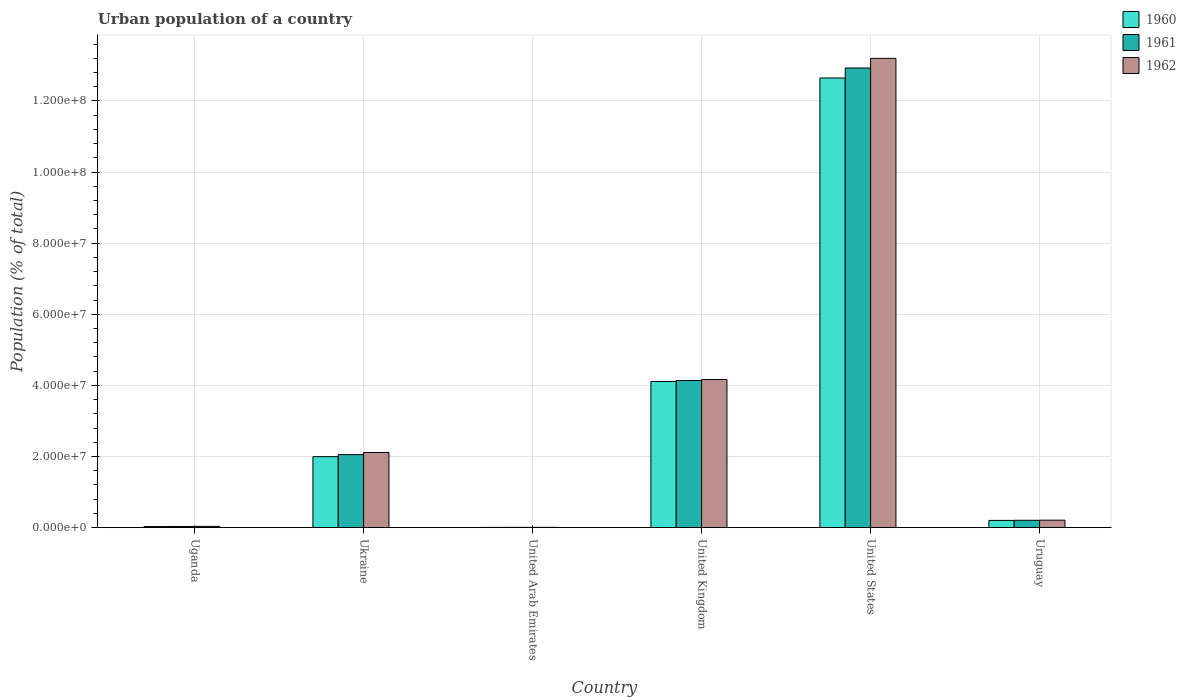How many different coloured bars are there?
Offer a very short reply. 3. How many groups of bars are there?
Your answer should be compact. 6. Are the number of bars on each tick of the X-axis equal?
Ensure brevity in your answer.  Yes. How many bars are there on the 3rd tick from the left?
Your response must be concise. 3. What is the label of the 1st group of bars from the left?
Ensure brevity in your answer.  Uganda. What is the urban population in 1960 in United Arab Emirates?
Give a very brief answer. 6.81e+04. Across all countries, what is the maximum urban population in 1961?
Your answer should be very brief. 1.29e+08. Across all countries, what is the minimum urban population in 1961?
Provide a succinct answer. 7.51e+04. In which country was the urban population in 1960 minimum?
Offer a terse response. United Arab Emirates. What is the total urban population in 1961 in the graph?
Keep it short and to the point. 1.94e+08. What is the difference between the urban population in 1961 in United Arab Emirates and that in Uruguay?
Offer a very short reply. -1.99e+06. What is the difference between the urban population in 1962 in Uganda and the urban population in 1960 in Uruguay?
Keep it short and to the point. -1.69e+06. What is the average urban population in 1960 per country?
Your answer should be very brief. 3.17e+07. What is the difference between the urban population of/in 1962 and urban population of/in 1960 in Uruguay?
Your answer should be very brief. 6.38e+04. What is the ratio of the urban population in 1962 in Uganda to that in United States?
Give a very brief answer. 0. Is the urban population in 1962 in Uganda less than that in Ukraine?
Offer a very short reply. Yes. What is the difference between the highest and the second highest urban population in 1962?
Make the answer very short. -2.05e+07. What is the difference between the highest and the lowest urban population in 1961?
Give a very brief answer. 1.29e+08. In how many countries, is the urban population in 1962 greater than the average urban population in 1962 taken over all countries?
Provide a short and direct response. 2. Is the sum of the urban population in 1961 in Uganda and Ukraine greater than the maximum urban population in 1962 across all countries?
Your response must be concise. No. What does the 1st bar from the left in United Kingdom represents?
Provide a succinct answer. 1960. Is it the case that in every country, the sum of the urban population in 1960 and urban population in 1962 is greater than the urban population in 1961?
Your answer should be compact. Yes. How many bars are there?
Offer a very short reply. 18. Are all the bars in the graph horizontal?
Your answer should be very brief. No. Are the values on the major ticks of Y-axis written in scientific E-notation?
Make the answer very short. Yes. Where does the legend appear in the graph?
Ensure brevity in your answer.  Top right. How many legend labels are there?
Provide a succinct answer. 3. How are the legend labels stacked?
Provide a succinct answer. Vertical. What is the title of the graph?
Offer a very short reply. Urban population of a country. Does "1982" appear as one of the legend labels in the graph?
Give a very brief answer. No. What is the label or title of the Y-axis?
Provide a short and direct response. Population (% of total). What is the Population (% of total) of 1960 in Uganda?
Offer a terse response. 3.00e+05. What is the Population (% of total) of 1961 in Uganda?
Your answer should be compact. 3.23e+05. What is the Population (% of total) of 1962 in Uganda?
Your answer should be compact. 3.49e+05. What is the Population (% of total) of 1960 in Ukraine?
Ensure brevity in your answer.  2.00e+07. What is the Population (% of total) of 1961 in Ukraine?
Provide a short and direct response. 2.05e+07. What is the Population (% of total) of 1962 in Ukraine?
Offer a very short reply. 2.11e+07. What is the Population (% of total) in 1960 in United Arab Emirates?
Ensure brevity in your answer.  6.81e+04. What is the Population (% of total) of 1961 in United Arab Emirates?
Offer a very short reply. 7.51e+04. What is the Population (% of total) of 1962 in United Arab Emirates?
Make the answer very short. 8.45e+04. What is the Population (% of total) of 1960 in United Kingdom?
Offer a very short reply. 4.11e+07. What is the Population (% of total) of 1961 in United Kingdom?
Give a very brief answer. 4.14e+07. What is the Population (% of total) in 1962 in United Kingdom?
Give a very brief answer. 4.17e+07. What is the Population (% of total) in 1960 in United States?
Give a very brief answer. 1.26e+08. What is the Population (% of total) of 1961 in United States?
Your answer should be very brief. 1.29e+08. What is the Population (% of total) of 1962 in United States?
Make the answer very short. 1.32e+08. What is the Population (% of total) in 1960 in Uruguay?
Your response must be concise. 2.04e+06. What is the Population (% of total) in 1961 in Uruguay?
Give a very brief answer. 2.07e+06. What is the Population (% of total) of 1962 in Uruguay?
Make the answer very short. 2.10e+06. Across all countries, what is the maximum Population (% of total) in 1960?
Your answer should be very brief. 1.26e+08. Across all countries, what is the maximum Population (% of total) in 1961?
Your answer should be very brief. 1.29e+08. Across all countries, what is the maximum Population (% of total) of 1962?
Your answer should be compact. 1.32e+08. Across all countries, what is the minimum Population (% of total) in 1960?
Offer a very short reply. 6.81e+04. Across all countries, what is the minimum Population (% of total) of 1961?
Make the answer very short. 7.51e+04. Across all countries, what is the minimum Population (% of total) of 1962?
Make the answer very short. 8.45e+04. What is the total Population (% of total) in 1960 in the graph?
Keep it short and to the point. 1.90e+08. What is the total Population (% of total) in 1961 in the graph?
Make the answer very short. 1.94e+08. What is the total Population (% of total) of 1962 in the graph?
Your response must be concise. 1.97e+08. What is the difference between the Population (% of total) of 1960 in Uganda and that in Ukraine?
Give a very brief answer. -1.97e+07. What is the difference between the Population (% of total) in 1961 in Uganda and that in Ukraine?
Give a very brief answer. -2.02e+07. What is the difference between the Population (% of total) in 1962 in Uganda and that in Ukraine?
Ensure brevity in your answer.  -2.08e+07. What is the difference between the Population (% of total) in 1960 in Uganda and that in United Arab Emirates?
Offer a very short reply. 2.32e+05. What is the difference between the Population (% of total) of 1961 in Uganda and that in United Arab Emirates?
Your answer should be compact. 2.48e+05. What is the difference between the Population (% of total) of 1962 in Uganda and that in United Arab Emirates?
Your answer should be compact. 2.65e+05. What is the difference between the Population (% of total) in 1960 in Uganda and that in United Kingdom?
Make the answer very short. -4.08e+07. What is the difference between the Population (% of total) in 1961 in Uganda and that in United Kingdom?
Give a very brief answer. -4.11e+07. What is the difference between the Population (% of total) of 1962 in Uganda and that in United Kingdom?
Offer a terse response. -4.13e+07. What is the difference between the Population (% of total) in 1960 in Uganda and that in United States?
Your answer should be compact. -1.26e+08. What is the difference between the Population (% of total) in 1961 in Uganda and that in United States?
Offer a very short reply. -1.29e+08. What is the difference between the Population (% of total) in 1962 in Uganda and that in United States?
Provide a short and direct response. -1.32e+08. What is the difference between the Population (% of total) of 1960 in Uganda and that in Uruguay?
Your answer should be very brief. -1.74e+06. What is the difference between the Population (% of total) in 1961 in Uganda and that in Uruguay?
Make the answer very short. -1.75e+06. What is the difference between the Population (% of total) of 1962 in Uganda and that in Uruguay?
Give a very brief answer. -1.75e+06. What is the difference between the Population (% of total) of 1960 in Ukraine and that in United Arab Emirates?
Offer a very short reply. 1.99e+07. What is the difference between the Population (% of total) of 1961 in Ukraine and that in United Arab Emirates?
Provide a succinct answer. 2.05e+07. What is the difference between the Population (% of total) in 1962 in Ukraine and that in United Arab Emirates?
Your answer should be compact. 2.10e+07. What is the difference between the Population (% of total) of 1960 in Ukraine and that in United Kingdom?
Offer a terse response. -2.11e+07. What is the difference between the Population (% of total) in 1961 in Ukraine and that in United Kingdom?
Ensure brevity in your answer.  -2.08e+07. What is the difference between the Population (% of total) in 1962 in Ukraine and that in United Kingdom?
Provide a short and direct response. -2.05e+07. What is the difference between the Population (% of total) in 1960 in Ukraine and that in United States?
Your answer should be compact. -1.06e+08. What is the difference between the Population (% of total) of 1961 in Ukraine and that in United States?
Give a very brief answer. -1.09e+08. What is the difference between the Population (% of total) of 1962 in Ukraine and that in United States?
Provide a short and direct response. -1.11e+08. What is the difference between the Population (% of total) in 1960 in Ukraine and that in Uruguay?
Offer a terse response. 1.79e+07. What is the difference between the Population (% of total) in 1961 in Ukraine and that in Uruguay?
Ensure brevity in your answer.  1.85e+07. What is the difference between the Population (% of total) of 1962 in Ukraine and that in Uruguay?
Ensure brevity in your answer.  1.90e+07. What is the difference between the Population (% of total) in 1960 in United Arab Emirates and that in United Kingdom?
Keep it short and to the point. -4.10e+07. What is the difference between the Population (% of total) in 1961 in United Arab Emirates and that in United Kingdom?
Your answer should be very brief. -4.13e+07. What is the difference between the Population (% of total) of 1962 in United Arab Emirates and that in United Kingdom?
Offer a very short reply. -4.16e+07. What is the difference between the Population (% of total) of 1960 in United Arab Emirates and that in United States?
Provide a succinct answer. -1.26e+08. What is the difference between the Population (% of total) of 1961 in United Arab Emirates and that in United States?
Make the answer very short. -1.29e+08. What is the difference between the Population (% of total) in 1962 in United Arab Emirates and that in United States?
Offer a terse response. -1.32e+08. What is the difference between the Population (% of total) in 1960 in United Arab Emirates and that in Uruguay?
Your answer should be very brief. -1.97e+06. What is the difference between the Population (% of total) of 1961 in United Arab Emirates and that in Uruguay?
Your answer should be very brief. -1.99e+06. What is the difference between the Population (% of total) of 1962 in United Arab Emirates and that in Uruguay?
Provide a short and direct response. -2.02e+06. What is the difference between the Population (% of total) in 1960 in United Kingdom and that in United States?
Keep it short and to the point. -8.54e+07. What is the difference between the Population (% of total) of 1961 in United Kingdom and that in United States?
Give a very brief answer. -8.79e+07. What is the difference between the Population (% of total) in 1962 in United Kingdom and that in United States?
Keep it short and to the point. -9.03e+07. What is the difference between the Population (% of total) in 1960 in United Kingdom and that in Uruguay?
Your answer should be very brief. 3.91e+07. What is the difference between the Population (% of total) in 1961 in United Kingdom and that in Uruguay?
Offer a terse response. 3.93e+07. What is the difference between the Population (% of total) of 1962 in United Kingdom and that in Uruguay?
Make the answer very short. 3.96e+07. What is the difference between the Population (% of total) of 1960 in United States and that in Uruguay?
Make the answer very short. 1.24e+08. What is the difference between the Population (% of total) in 1961 in United States and that in Uruguay?
Provide a succinct answer. 1.27e+08. What is the difference between the Population (% of total) in 1962 in United States and that in Uruguay?
Your answer should be very brief. 1.30e+08. What is the difference between the Population (% of total) of 1960 in Uganda and the Population (% of total) of 1961 in Ukraine?
Offer a terse response. -2.02e+07. What is the difference between the Population (% of total) in 1960 in Uganda and the Population (% of total) in 1962 in Ukraine?
Your response must be concise. -2.08e+07. What is the difference between the Population (% of total) of 1961 in Uganda and the Population (% of total) of 1962 in Ukraine?
Provide a succinct answer. -2.08e+07. What is the difference between the Population (% of total) in 1960 in Uganda and the Population (% of total) in 1961 in United Arab Emirates?
Your answer should be very brief. 2.25e+05. What is the difference between the Population (% of total) of 1960 in Uganda and the Population (% of total) of 1962 in United Arab Emirates?
Offer a terse response. 2.15e+05. What is the difference between the Population (% of total) in 1961 in Uganda and the Population (% of total) in 1962 in United Arab Emirates?
Your response must be concise. 2.39e+05. What is the difference between the Population (% of total) of 1960 in Uganda and the Population (% of total) of 1961 in United Kingdom?
Make the answer very short. -4.11e+07. What is the difference between the Population (% of total) of 1960 in Uganda and the Population (% of total) of 1962 in United Kingdom?
Offer a very short reply. -4.14e+07. What is the difference between the Population (% of total) in 1961 in Uganda and the Population (% of total) in 1962 in United Kingdom?
Give a very brief answer. -4.13e+07. What is the difference between the Population (% of total) in 1960 in Uganda and the Population (% of total) in 1961 in United States?
Provide a succinct answer. -1.29e+08. What is the difference between the Population (% of total) of 1960 in Uganda and the Population (% of total) of 1962 in United States?
Provide a succinct answer. -1.32e+08. What is the difference between the Population (% of total) of 1961 in Uganda and the Population (% of total) of 1962 in United States?
Provide a short and direct response. -1.32e+08. What is the difference between the Population (% of total) in 1960 in Uganda and the Population (% of total) in 1961 in Uruguay?
Give a very brief answer. -1.77e+06. What is the difference between the Population (% of total) of 1960 in Uganda and the Population (% of total) of 1962 in Uruguay?
Make the answer very short. -1.80e+06. What is the difference between the Population (% of total) in 1961 in Uganda and the Population (% of total) in 1962 in Uruguay?
Give a very brief answer. -1.78e+06. What is the difference between the Population (% of total) of 1960 in Ukraine and the Population (% of total) of 1961 in United Arab Emirates?
Give a very brief answer. 1.99e+07. What is the difference between the Population (% of total) of 1960 in Ukraine and the Population (% of total) of 1962 in United Arab Emirates?
Your answer should be very brief. 1.99e+07. What is the difference between the Population (% of total) of 1961 in Ukraine and the Population (% of total) of 1962 in United Arab Emirates?
Your answer should be very brief. 2.05e+07. What is the difference between the Population (% of total) of 1960 in Ukraine and the Population (% of total) of 1961 in United Kingdom?
Provide a short and direct response. -2.14e+07. What is the difference between the Population (% of total) in 1960 in Ukraine and the Population (% of total) in 1962 in United Kingdom?
Ensure brevity in your answer.  -2.17e+07. What is the difference between the Population (% of total) in 1961 in Ukraine and the Population (% of total) in 1962 in United Kingdom?
Your answer should be compact. -2.11e+07. What is the difference between the Population (% of total) in 1960 in Ukraine and the Population (% of total) in 1961 in United States?
Provide a succinct answer. -1.09e+08. What is the difference between the Population (% of total) of 1960 in Ukraine and the Population (% of total) of 1962 in United States?
Offer a terse response. -1.12e+08. What is the difference between the Population (% of total) in 1961 in Ukraine and the Population (% of total) in 1962 in United States?
Your response must be concise. -1.11e+08. What is the difference between the Population (% of total) of 1960 in Ukraine and the Population (% of total) of 1961 in Uruguay?
Your answer should be very brief. 1.79e+07. What is the difference between the Population (% of total) of 1960 in Ukraine and the Population (% of total) of 1962 in Uruguay?
Keep it short and to the point. 1.79e+07. What is the difference between the Population (% of total) in 1961 in Ukraine and the Population (% of total) in 1962 in Uruguay?
Provide a succinct answer. 1.84e+07. What is the difference between the Population (% of total) of 1960 in United Arab Emirates and the Population (% of total) of 1961 in United Kingdom?
Give a very brief answer. -4.13e+07. What is the difference between the Population (% of total) of 1960 in United Arab Emirates and the Population (% of total) of 1962 in United Kingdom?
Your answer should be very brief. -4.16e+07. What is the difference between the Population (% of total) of 1961 in United Arab Emirates and the Population (% of total) of 1962 in United Kingdom?
Provide a short and direct response. -4.16e+07. What is the difference between the Population (% of total) in 1960 in United Arab Emirates and the Population (% of total) in 1961 in United States?
Provide a short and direct response. -1.29e+08. What is the difference between the Population (% of total) in 1960 in United Arab Emirates and the Population (% of total) in 1962 in United States?
Make the answer very short. -1.32e+08. What is the difference between the Population (% of total) of 1961 in United Arab Emirates and the Population (% of total) of 1962 in United States?
Provide a short and direct response. -1.32e+08. What is the difference between the Population (% of total) in 1960 in United Arab Emirates and the Population (% of total) in 1961 in Uruguay?
Offer a very short reply. -2.00e+06. What is the difference between the Population (% of total) of 1960 in United Arab Emirates and the Population (% of total) of 1962 in Uruguay?
Make the answer very short. -2.03e+06. What is the difference between the Population (% of total) of 1961 in United Arab Emirates and the Population (% of total) of 1962 in Uruguay?
Your answer should be compact. -2.03e+06. What is the difference between the Population (% of total) of 1960 in United Kingdom and the Population (% of total) of 1961 in United States?
Your answer should be very brief. -8.82e+07. What is the difference between the Population (% of total) of 1960 in United Kingdom and the Population (% of total) of 1962 in United States?
Ensure brevity in your answer.  -9.09e+07. What is the difference between the Population (% of total) in 1961 in United Kingdom and the Population (% of total) in 1962 in United States?
Offer a very short reply. -9.06e+07. What is the difference between the Population (% of total) of 1960 in United Kingdom and the Population (% of total) of 1961 in Uruguay?
Your answer should be very brief. 3.90e+07. What is the difference between the Population (% of total) of 1960 in United Kingdom and the Population (% of total) of 1962 in Uruguay?
Offer a very short reply. 3.90e+07. What is the difference between the Population (% of total) in 1961 in United Kingdom and the Population (% of total) in 1962 in Uruguay?
Offer a terse response. 3.93e+07. What is the difference between the Population (% of total) of 1960 in United States and the Population (% of total) of 1961 in Uruguay?
Keep it short and to the point. 1.24e+08. What is the difference between the Population (% of total) in 1960 in United States and the Population (% of total) in 1962 in Uruguay?
Offer a terse response. 1.24e+08. What is the difference between the Population (% of total) of 1961 in United States and the Population (% of total) of 1962 in Uruguay?
Make the answer very short. 1.27e+08. What is the average Population (% of total) of 1960 per country?
Offer a very short reply. 3.17e+07. What is the average Population (% of total) in 1961 per country?
Make the answer very short. 3.23e+07. What is the average Population (% of total) in 1962 per country?
Provide a short and direct response. 3.29e+07. What is the difference between the Population (% of total) of 1960 and Population (% of total) of 1961 in Uganda?
Provide a succinct answer. -2.37e+04. What is the difference between the Population (% of total) in 1960 and Population (% of total) in 1962 in Uganda?
Offer a very short reply. -4.96e+04. What is the difference between the Population (% of total) of 1961 and Population (% of total) of 1962 in Uganda?
Offer a very short reply. -2.59e+04. What is the difference between the Population (% of total) in 1960 and Population (% of total) in 1961 in Ukraine?
Your answer should be compact. -5.77e+05. What is the difference between the Population (% of total) in 1960 and Population (% of total) in 1962 in Ukraine?
Give a very brief answer. -1.17e+06. What is the difference between the Population (% of total) in 1961 and Population (% of total) in 1962 in Ukraine?
Your answer should be very brief. -5.88e+05. What is the difference between the Population (% of total) of 1960 and Population (% of total) of 1961 in United Arab Emirates?
Offer a very short reply. -7046. What is the difference between the Population (% of total) of 1960 and Population (% of total) of 1962 in United Arab Emirates?
Ensure brevity in your answer.  -1.64e+04. What is the difference between the Population (% of total) in 1961 and Population (% of total) in 1962 in United Arab Emirates?
Your answer should be compact. -9342. What is the difference between the Population (% of total) of 1960 and Population (% of total) of 1961 in United Kingdom?
Ensure brevity in your answer.  -2.77e+05. What is the difference between the Population (% of total) in 1960 and Population (% of total) in 1962 in United Kingdom?
Ensure brevity in your answer.  -5.57e+05. What is the difference between the Population (% of total) of 1961 and Population (% of total) of 1962 in United Kingdom?
Your answer should be very brief. -2.80e+05. What is the difference between the Population (% of total) in 1960 and Population (% of total) in 1961 in United States?
Your answer should be compact. -2.81e+06. What is the difference between the Population (% of total) of 1960 and Population (% of total) of 1962 in United States?
Your answer should be compact. -5.53e+06. What is the difference between the Population (% of total) in 1961 and Population (% of total) in 1962 in United States?
Give a very brief answer. -2.71e+06. What is the difference between the Population (% of total) in 1960 and Population (% of total) in 1961 in Uruguay?
Your answer should be very brief. -3.22e+04. What is the difference between the Population (% of total) in 1960 and Population (% of total) in 1962 in Uruguay?
Ensure brevity in your answer.  -6.38e+04. What is the difference between the Population (% of total) in 1961 and Population (% of total) in 1962 in Uruguay?
Keep it short and to the point. -3.16e+04. What is the ratio of the Population (% of total) in 1960 in Uganda to that in Ukraine?
Provide a succinct answer. 0.01. What is the ratio of the Population (% of total) of 1961 in Uganda to that in Ukraine?
Provide a short and direct response. 0.02. What is the ratio of the Population (% of total) of 1962 in Uganda to that in Ukraine?
Your answer should be very brief. 0.02. What is the ratio of the Population (% of total) of 1960 in Uganda to that in United Arab Emirates?
Provide a short and direct response. 4.4. What is the ratio of the Population (% of total) of 1961 in Uganda to that in United Arab Emirates?
Give a very brief answer. 4.31. What is the ratio of the Population (% of total) in 1962 in Uganda to that in United Arab Emirates?
Keep it short and to the point. 4.14. What is the ratio of the Population (% of total) of 1960 in Uganda to that in United Kingdom?
Ensure brevity in your answer.  0.01. What is the ratio of the Population (% of total) of 1961 in Uganda to that in United Kingdom?
Offer a very short reply. 0.01. What is the ratio of the Population (% of total) of 1962 in Uganda to that in United Kingdom?
Make the answer very short. 0.01. What is the ratio of the Population (% of total) of 1960 in Uganda to that in United States?
Offer a terse response. 0. What is the ratio of the Population (% of total) of 1961 in Uganda to that in United States?
Make the answer very short. 0. What is the ratio of the Population (% of total) of 1962 in Uganda to that in United States?
Your answer should be compact. 0. What is the ratio of the Population (% of total) in 1960 in Uganda to that in Uruguay?
Provide a succinct answer. 0.15. What is the ratio of the Population (% of total) in 1961 in Uganda to that in Uruguay?
Your answer should be very brief. 0.16. What is the ratio of the Population (% of total) in 1962 in Uganda to that in Uruguay?
Give a very brief answer. 0.17. What is the ratio of the Population (% of total) of 1960 in Ukraine to that in United Arab Emirates?
Offer a very short reply. 293.26. What is the ratio of the Population (% of total) in 1961 in Ukraine to that in United Arab Emirates?
Ensure brevity in your answer.  273.44. What is the ratio of the Population (% of total) of 1962 in Ukraine to that in United Arab Emirates?
Ensure brevity in your answer.  250.16. What is the ratio of the Population (% of total) in 1960 in Ukraine to that in United Kingdom?
Your response must be concise. 0.49. What is the ratio of the Population (% of total) in 1961 in Ukraine to that in United Kingdom?
Ensure brevity in your answer.  0.5. What is the ratio of the Population (% of total) in 1962 in Ukraine to that in United Kingdom?
Provide a succinct answer. 0.51. What is the ratio of the Population (% of total) of 1960 in Ukraine to that in United States?
Keep it short and to the point. 0.16. What is the ratio of the Population (% of total) in 1961 in Ukraine to that in United States?
Keep it short and to the point. 0.16. What is the ratio of the Population (% of total) of 1962 in Ukraine to that in United States?
Make the answer very short. 0.16. What is the ratio of the Population (% of total) of 1960 in Ukraine to that in Uruguay?
Keep it short and to the point. 9.8. What is the ratio of the Population (% of total) in 1961 in Ukraine to that in Uruguay?
Give a very brief answer. 9.93. What is the ratio of the Population (% of total) in 1962 in Ukraine to that in Uruguay?
Ensure brevity in your answer.  10.06. What is the ratio of the Population (% of total) of 1960 in United Arab Emirates to that in United Kingdom?
Offer a terse response. 0. What is the ratio of the Population (% of total) of 1961 in United Arab Emirates to that in United Kingdom?
Keep it short and to the point. 0. What is the ratio of the Population (% of total) of 1962 in United Arab Emirates to that in United Kingdom?
Keep it short and to the point. 0. What is the ratio of the Population (% of total) in 1960 in United Arab Emirates to that in United States?
Your response must be concise. 0. What is the ratio of the Population (% of total) of 1961 in United Arab Emirates to that in United States?
Make the answer very short. 0. What is the ratio of the Population (% of total) in 1962 in United Arab Emirates to that in United States?
Provide a short and direct response. 0. What is the ratio of the Population (% of total) of 1960 in United Arab Emirates to that in Uruguay?
Give a very brief answer. 0.03. What is the ratio of the Population (% of total) of 1961 in United Arab Emirates to that in Uruguay?
Your response must be concise. 0.04. What is the ratio of the Population (% of total) in 1962 in United Arab Emirates to that in Uruguay?
Your response must be concise. 0.04. What is the ratio of the Population (% of total) in 1960 in United Kingdom to that in United States?
Offer a very short reply. 0.33. What is the ratio of the Population (% of total) of 1961 in United Kingdom to that in United States?
Offer a very short reply. 0.32. What is the ratio of the Population (% of total) of 1962 in United Kingdom to that in United States?
Your response must be concise. 0.32. What is the ratio of the Population (% of total) in 1960 in United Kingdom to that in Uruguay?
Make the answer very short. 20.18. What is the ratio of the Population (% of total) of 1961 in United Kingdom to that in Uruguay?
Your response must be concise. 20. What is the ratio of the Population (% of total) in 1962 in United Kingdom to that in Uruguay?
Provide a succinct answer. 19.83. What is the ratio of the Population (% of total) in 1960 in United States to that in Uruguay?
Your answer should be very brief. 62.08. What is the ratio of the Population (% of total) of 1961 in United States to that in Uruguay?
Keep it short and to the point. 62.48. What is the ratio of the Population (% of total) in 1962 in United States to that in Uruguay?
Keep it short and to the point. 62.83. What is the difference between the highest and the second highest Population (% of total) in 1960?
Offer a very short reply. 8.54e+07. What is the difference between the highest and the second highest Population (% of total) of 1961?
Your response must be concise. 8.79e+07. What is the difference between the highest and the second highest Population (% of total) in 1962?
Offer a terse response. 9.03e+07. What is the difference between the highest and the lowest Population (% of total) in 1960?
Provide a succinct answer. 1.26e+08. What is the difference between the highest and the lowest Population (% of total) in 1961?
Provide a short and direct response. 1.29e+08. What is the difference between the highest and the lowest Population (% of total) in 1962?
Offer a terse response. 1.32e+08. 